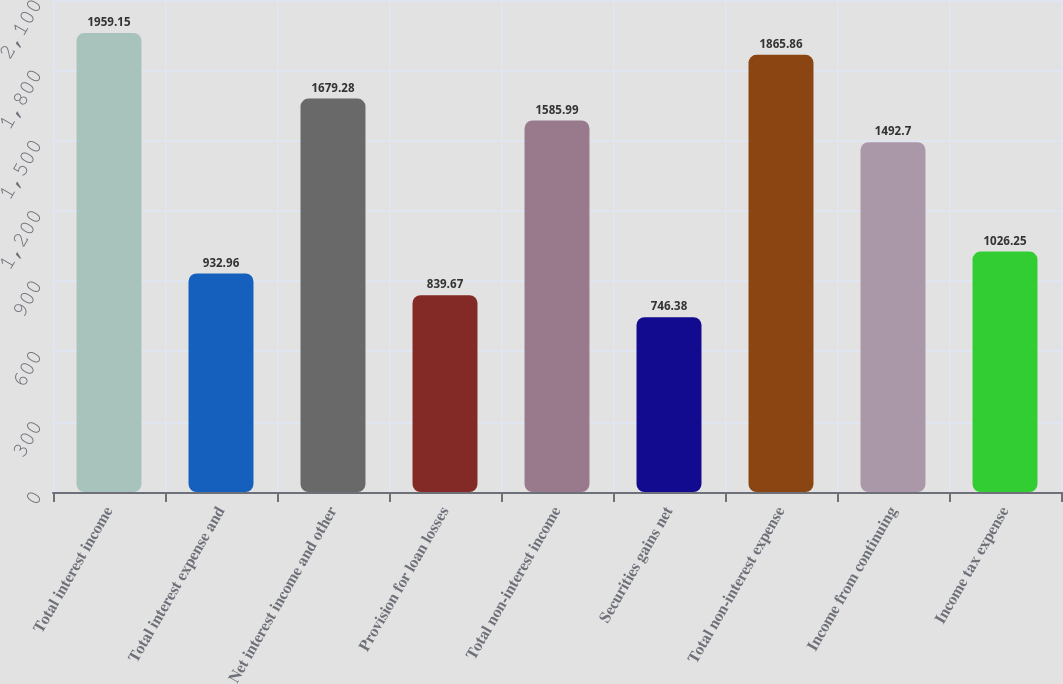<chart> <loc_0><loc_0><loc_500><loc_500><bar_chart><fcel>Total interest income<fcel>Total interest expense and<fcel>Net interest income and other<fcel>Provision for loan losses<fcel>Total non-interest income<fcel>Securities gains net<fcel>Total non-interest expense<fcel>Income from continuing<fcel>Income tax expense<nl><fcel>1959.15<fcel>932.96<fcel>1679.28<fcel>839.67<fcel>1585.99<fcel>746.38<fcel>1865.86<fcel>1492.7<fcel>1026.25<nl></chart> 